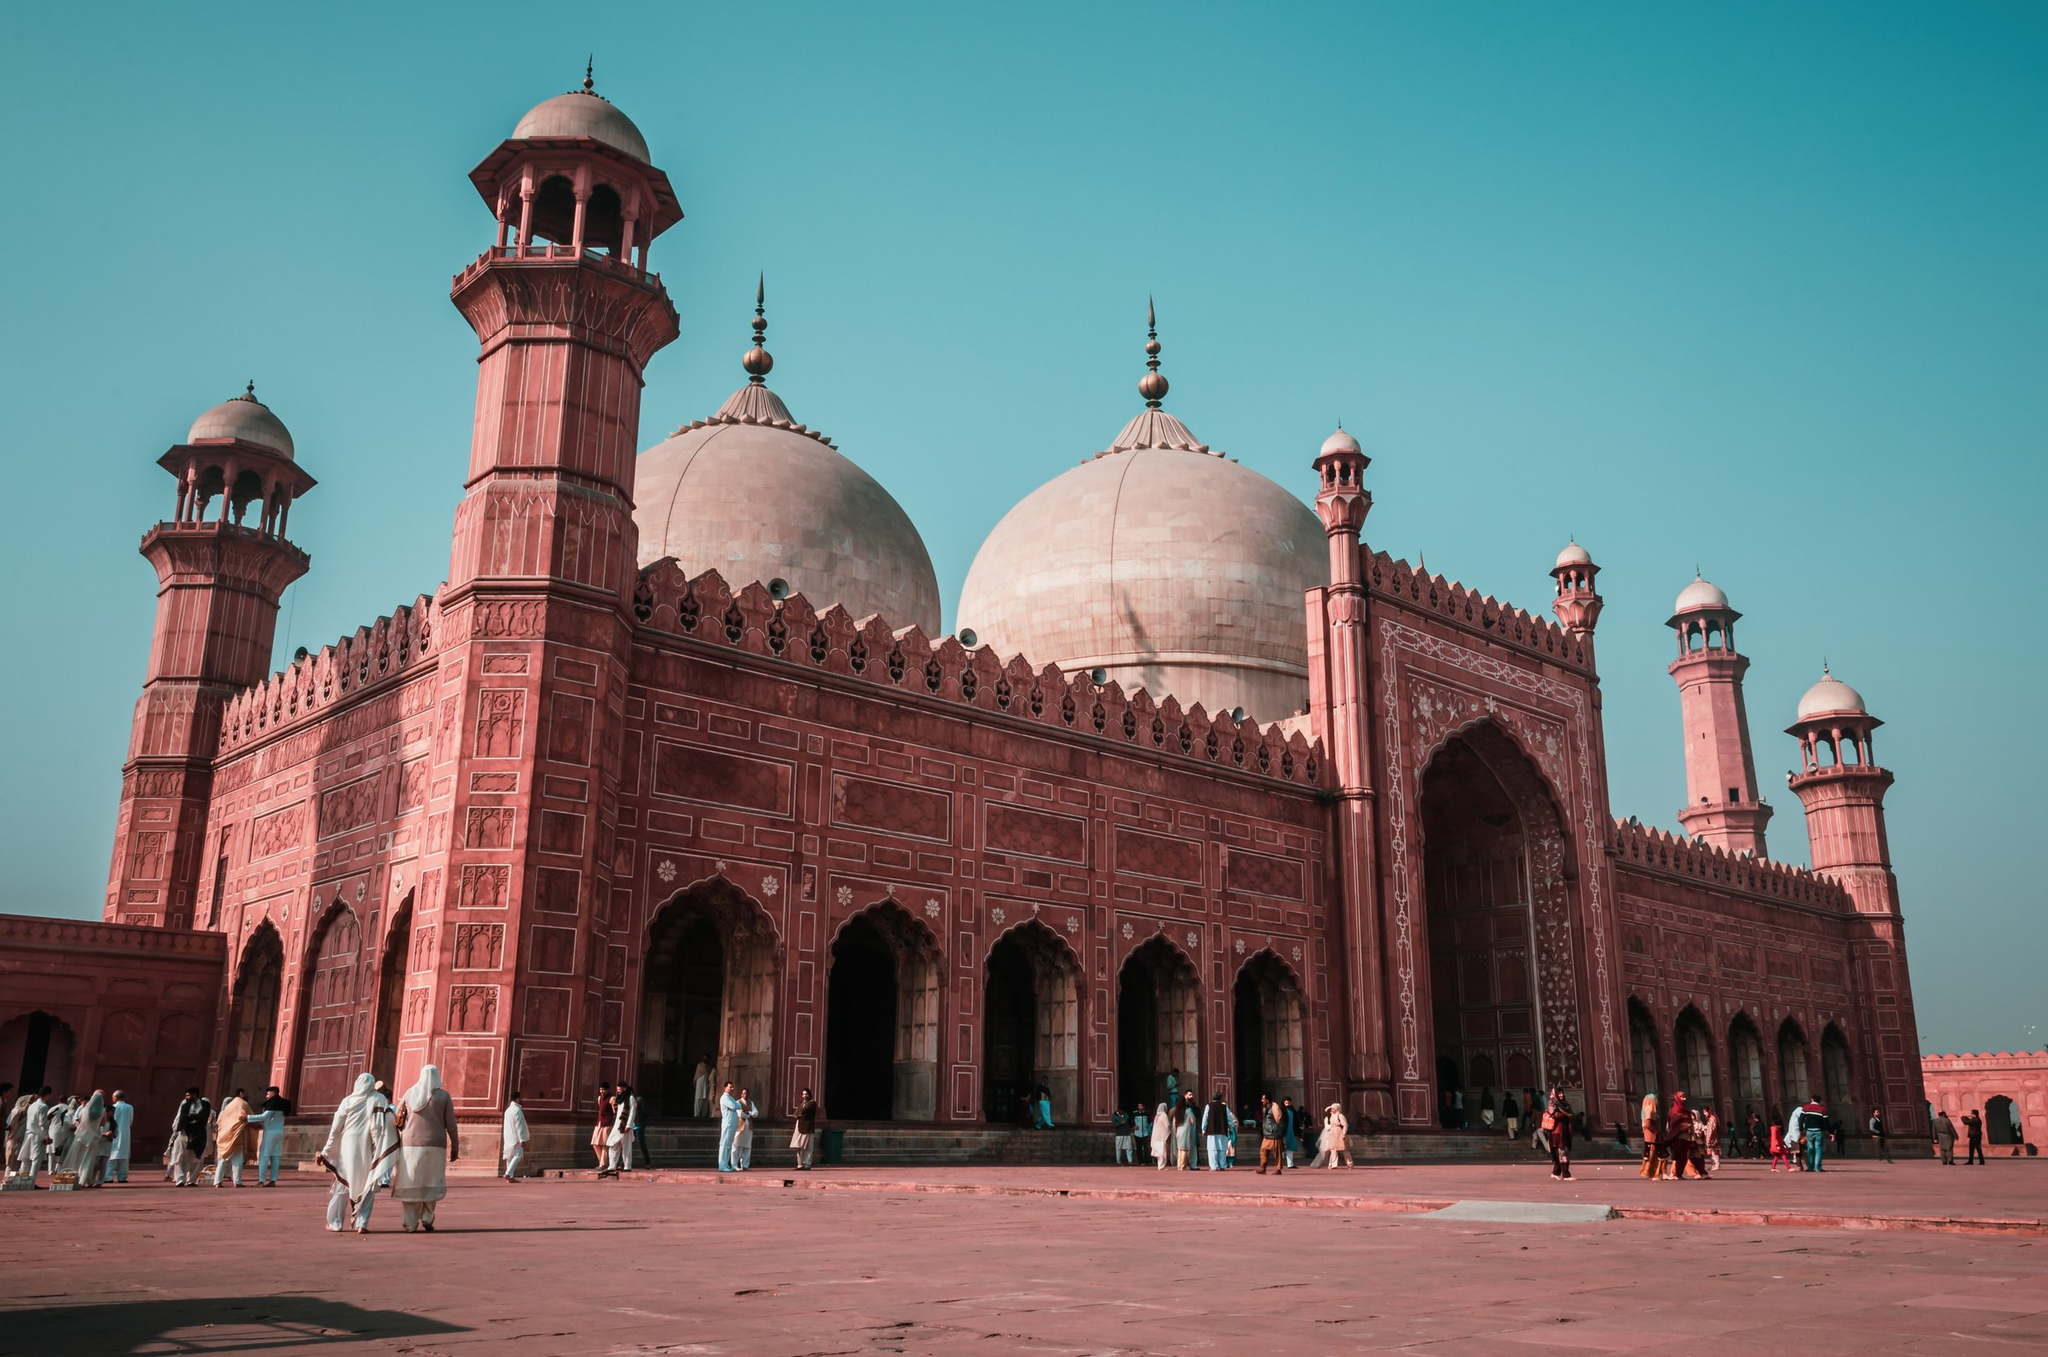Could you describe a day in the life of a person visiting this mosque? A day at the Badshahi Mosque begins with the morning call to prayer, echoing through the grand courtyard. Devotees, dressed in traditional attire, move towards the mosque's entrance, where they remove their shoes and perform ablutions. As they enter the main prayer hall, a sense of serene spirituality overcomes them within the intricate marble and sandstone sanctuary. Throughout the day, numerous visitors, both locals and tourists, explore the architectural marvels - marveling at the intricate mosaics and carvings, and capturing photographs. The courtyard is alive with families and friends spending quality time, children playing, and vendors selling traditional snacks. As the sun sets, the mosque is illuminated, amplifying its beauty against the twilight sky, and the azaan calls once again, marking an end to a spiritually fulfilling day. 